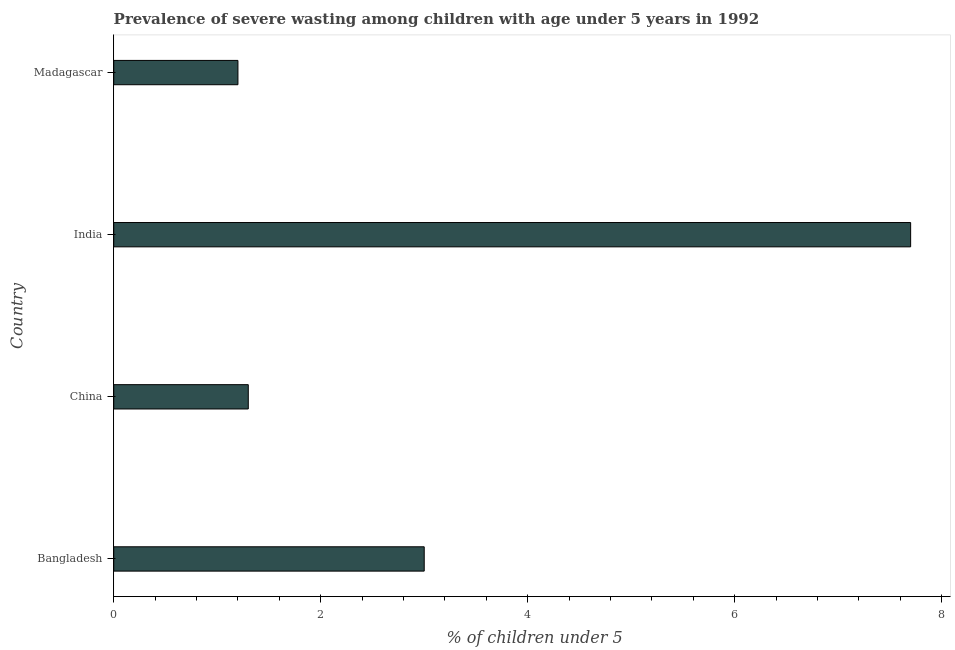Does the graph contain grids?
Your answer should be compact. No. What is the title of the graph?
Your response must be concise. Prevalence of severe wasting among children with age under 5 years in 1992. What is the label or title of the X-axis?
Offer a very short reply.  % of children under 5. What is the label or title of the Y-axis?
Your response must be concise. Country. What is the prevalence of severe wasting in China?
Ensure brevity in your answer.  1.3. Across all countries, what is the maximum prevalence of severe wasting?
Provide a short and direct response. 7.7. Across all countries, what is the minimum prevalence of severe wasting?
Your answer should be compact. 1.2. In which country was the prevalence of severe wasting maximum?
Make the answer very short. India. In which country was the prevalence of severe wasting minimum?
Offer a very short reply. Madagascar. What is the sum of the prevalence of severe wasting?
Give a very brief answer. 13.2. What is the difference between the prevalence of severe wasting in India and Madagascar?
Provide a short and direct response. 6.5. What is the median prevalence of severe wasting?
Offer a terse response. 2.15. What is the ratio of the prevalence of severe wasting in China to that in India?
Your answer should be very brief. 0.17. Is the difference between the prevalence of severe wasting in Bangladesh and Madagascar greater than the difference between any two countries?
Ensure brevity in your answer.  No. What is the difference between the highest and the second highest prevalence of severe wasting?
Ensure brevity in your answer.  4.7. Are all the bars in the graph horizontal?
Make the answer very short. Yes. What is the difference between two consecutive major ticks on the X-axis?
Keep it short and to the point. 2. Are the values on the major ticks of X-axis written in scientific E-notation?
Offer a terse response. No. What is the  % of children under 5 of China?
Offer a terse response. 1.3. What is the  % of children under 5 in India?
Give a very brief answer. 7.7. What is the  % of children under 5 in Madagascar?
Provide a succinct answer. 1.2. What is the difference between the  % of children under 5 in Bangladesh and India?
Your answer should be compact. -4.7. What is the difference between the  % of children under 5 in India and Madagascar?
Keep it short and to the point. 6.5. What is the ratio of the  % of children under 5 in Bangladesh to that in China?
Offer a terse response. 2.31. What is the ratio of the  % of children under 5 in Bangladesh to that in India?
Keep it short and to the point. 0.39. What is the ratio of the  % of children under 5 in China to that in India?
Keep it short and to the point. 0.17. What is the ratio of the  % of children under 5 in China to that in Madagascar?
Your answer should be very brief. 1.08. What is the ratio of the  % of children under 5 in India to that in Madagascar?
Keep it short and to the point. 6.42. 